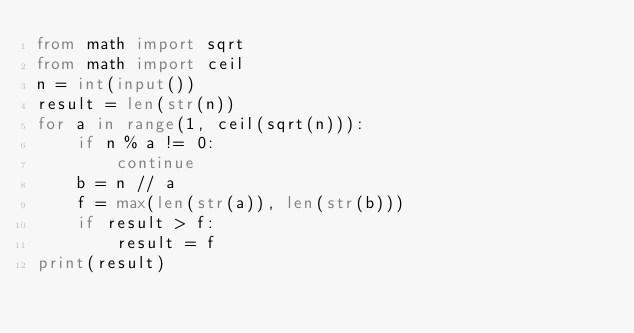Convert code to text. <code><loc_0><loc_0><loc_500><loc_500><_Python_>from math import sqrt
from math import ceil
n = int(input())
result = len(str(n))
for a in range(1, ceil(sqrt(n))):
    if n % a != 0:
        continue
    b = n // a
    f = max(len(str(a)), len(str(b)))
    if result > f:
        result = f
print(result)</code> 